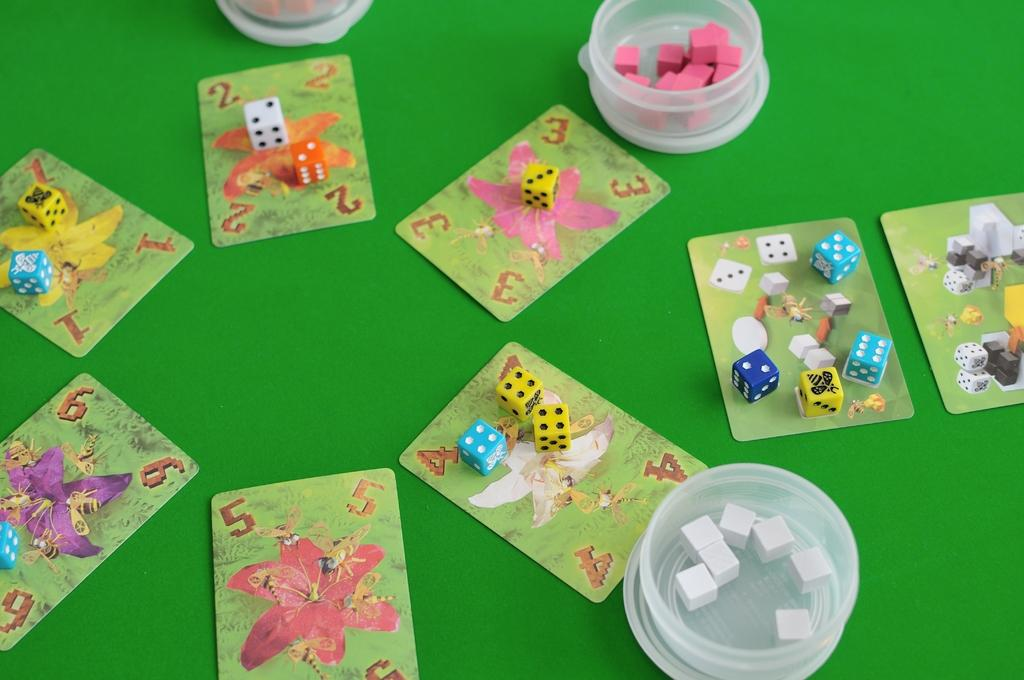What type of game-related items are present in the image? There are playing cards in the image, and dice are placed on the playing cards. What else can be seen in the image besides the playing cards and dice? There are small containers in the image, and objects are placed on either side of the small containers. How many dogs are playing with the crackers in the image? There are no dogs or crackers present in the image. Are there any rabbits visible in the image? There are no rabbits visible in the image. 